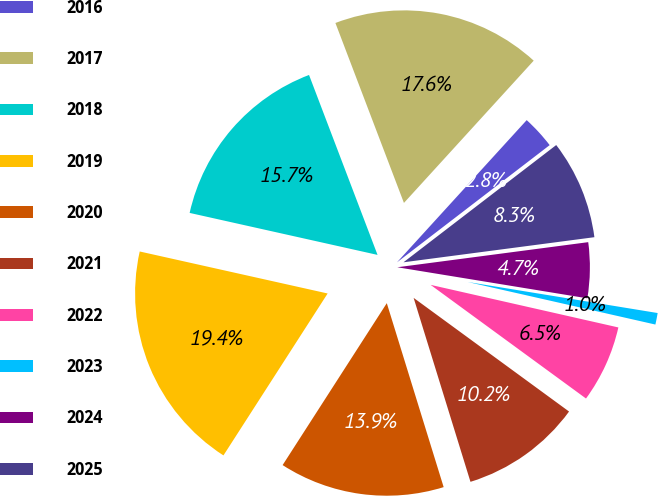<chart> <loc_0><loc_0><loc_500><loc_500><pie_chart><fcel>2016<fcel>2017<fcel>2018<fcel>2019<fcel>2020<fcel>2021<fcel>2022<fcel>2023<fcel>2024<fcel>2025<nl><fcel>2.81%<fcel>17.56%<fcel>15.71%<fcel>19.4%<fcel>13.87%<fcel>10.18%<fcel>6.5%<fcel>0.97%<fcel>4.66%<fcel>8.34%<nl></chart> 